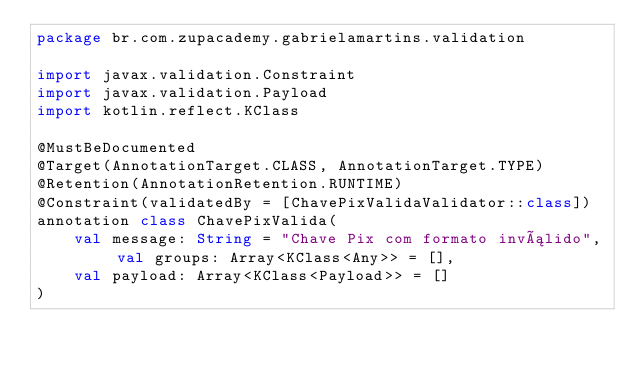Convert code to text. <code><loc_0><loc_0><loc_500><loc_500><_Kotlin_>package br.com.zupacademy.gabrielamartins.validation

import javax.validation.Constraint
import javax.validation.Payload
import kotlin.reflect.KClass

@MustBeDocumented
@Target(AnnotationTarget.CLASS, AnnotationTarget.TYPE)
@Retention(AnnotationRetention.RUNTIME)
@Constraint(validatedBy = [ChavePixValidaValidator::class])
annotation class ChavePixValida(
    val message: String = "Chave Pix com formato inválido", val groups: Array<KClass<Any>> = [],
    val payload: Array<KClass<Payload>> = []
)
</code> 